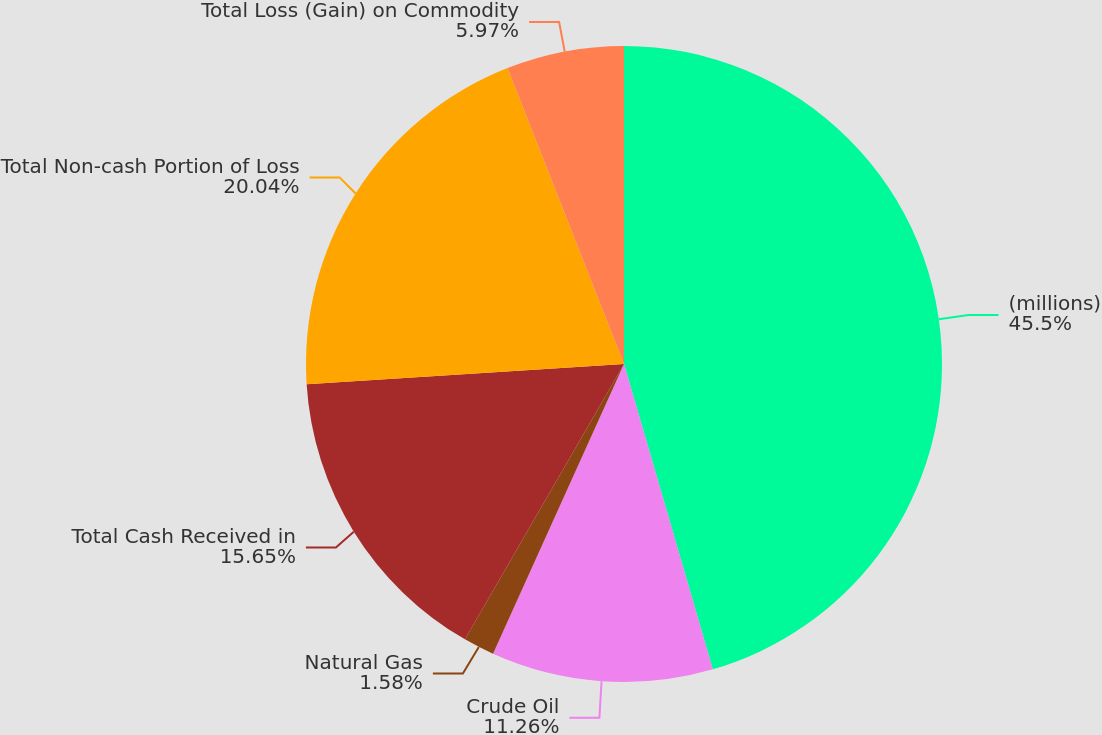Convert chart to OTSL. <chart><loc_0><loc_0><loc_500><loc_500><pie_chart><fcel>(millions)<fcel>Crude Oil<fcel>Natural Gas<fcel>Total Cash Received in<fcel>Total Non-cash Portion of Loss<fcel>Total Loss (Gain) on Commodity<nl><fcel>45.49%<fcel>11.26%<fcel>1.58%<fcel>15.65%<fcel>20.04%<fcel>5.97%<nl></chart> 